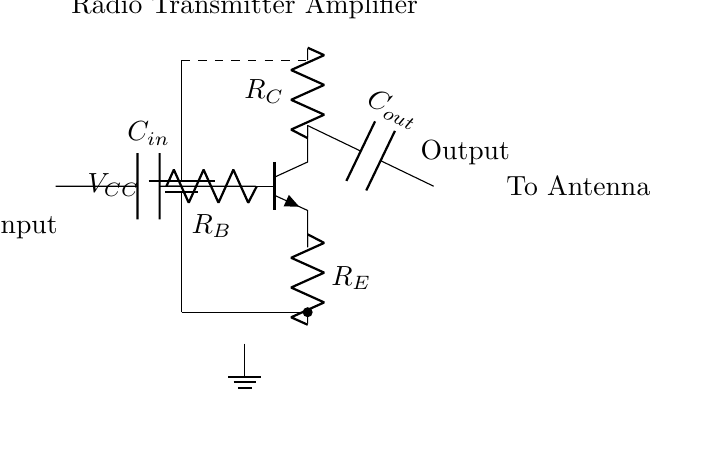What is the type of transistor used in this circuit? The circuit diagram shows an npn transistor symbol, indicating that the type of transistor is an npn.
Answer: npn What is the purpose of the capacitor labeled C in the circuit? Capacitors in amplifier circuits typically serve to couple AC signals; in this diagram, C is functioning as an input and output coupling capacitor, allowing AC signals to pass while blocking DC.
Answer: Coupling What does the resistor R_E do in this circuit? Resistor R_E, connected at the emitter of the transistor, stabilizes the transistor's bias point and affects the overall gain of the amplifier.
Answer: Stabilizes bias How does the output from the circuit reach the antenna? The output terminal is connected directly to the output capacitor, which signals that the amplified signal is sent toward the antenna for broadcasting.
Answer: Directly What is the input voltage in this circuit? The circuit indicates that the voltage source is labeled as V_CC, which often represents the main supply voltage; however the specific value is not stated in the diagram.
Answer: V_CC How does the transistor amplify the input signal? The transistor operates by allowing a small input current at the base to control a larger current between the collector and emitter, thus achieving amplification based on its gain characteristics.
Answer: By current control 